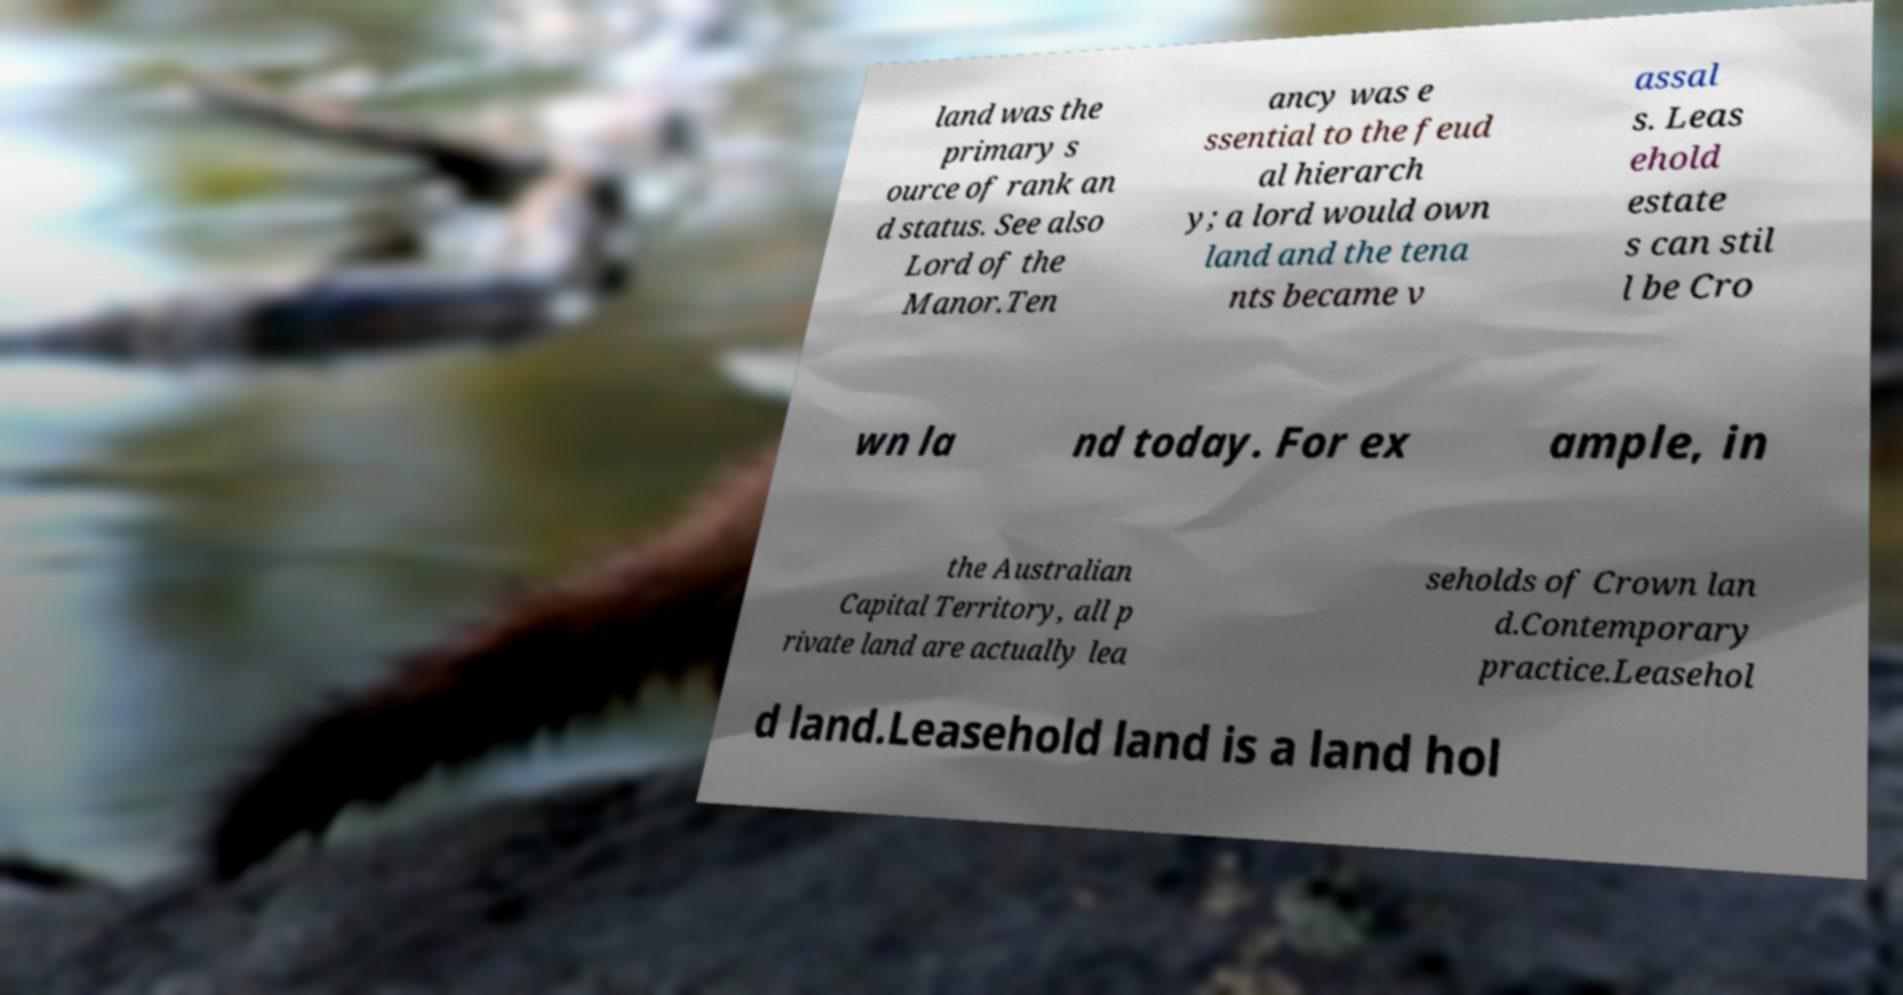Please read and relay the text visible in this image. What does it say? land was the primary s ource of rank an d status. See also Lord of the Manor.Ten ancy was e ssential to the feud al hierarch y; a lord would own land and the tena nts became v assal s. Leas ehold estate s can stil l be Cro wn la nd today. For ex ample, in the Australian Capital Territory, all p rivate land are actually lea seholds of Crown lan d.Contemporary practice.Leasehol d land.Leasehold land is a land hol 